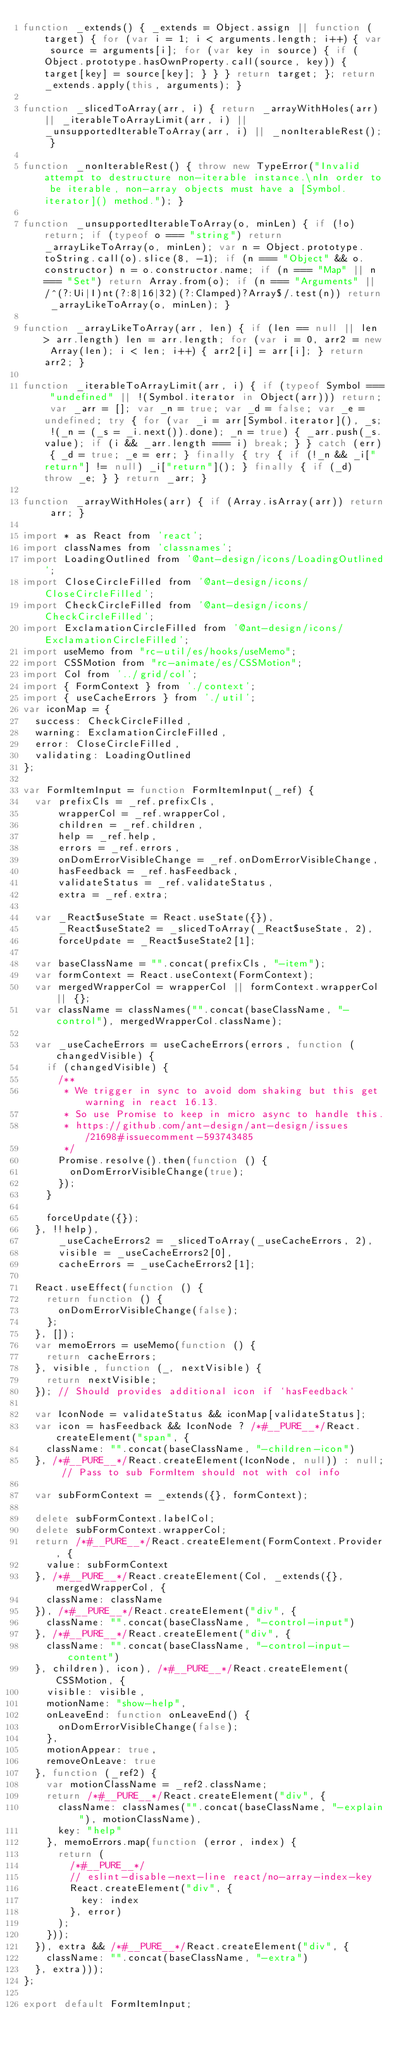Convert code to text. <code><loc_0><loc_0><loc_500><loc_500><_JavaScript_>function _extends() { _extends = Object.assign || function (target) { for (var i = 1; i < arguments.length; i++) { var source = arguments[i]; for (var key in source) { if (Object.prototype.hasOwnProperty.call(source, key)) { target[key] = source[key]; } } } return target; }; return _extends.apply(this, arguments); }

function _slicedToArray(arr, i) { return _arrayWithHoles(arr) || _iterableToArrayLimit(arr, i) || _unsupportedIterableToArray(arr, i) || _nonIterableRest(); }

function _nonIterableRest() { throw new TypeError("Invalid attempt to destructure non-iterable instance.\nIn order to be iterable, non-array objects must have a [Symbol.iterator]() method."); }

function _unsupportedIterableToArray(o, minLen) { if (!o) return; if (typeof o === "string") return _arrayLikeToArray(o, minLen); var n = Object.prototype.toString.call(o).slice(8, -1); if (n === "Object" && o.constructor) n = o.constructor.name; if (n === "Map" || n === "Set") return Array.from(o); if (n === "Arguments" || /^(?:Ui|I)nt(?:8|16|32)(?:Clamped)?Array$/.test(n)) return _arrayLikeToArray(o, minLen); }

function _arrayLikeToArray(arr, len) { if (len == null || len > arr.length) len = arr.length; for (var i = 0, arr2 = new Array(len); i < len; i++) { arr2[i] = arr[i]; } return arr2; }

function _iterableToArrayLimit(arr, i) { if (typeof Symbol === "undefined" || !(Symbol.iterator in Object(arr))) return; var _arr = []; var _n = true; var _d = false; var _e = undefined; try { for (var _i = arr[Symbol.iterator](), _s; !(_n = (_s = _i.next()).done); _n = true) { _arr.push(_s.value); if (i && _arr.length === i) break; } } catch (err) { _d = true; _e = err; } finally { try { if (!_n && _i["return"] != null) _i["return"](); } finally { if (_d) throw _e; } } return _arr; }

function _arrayWithHoles(arr) { if (Array.isArray(arr)) return arr; }

import * as React from 'react';
import classNames from 'classnames';
import LoadingOutlined from '@ant-design/icons/LoadingOutlined';
import CloseCircleFilled from '@ant-design/icons/CloseCircleFilled';
import CheckCircleFilled from '@ant-design/icons/CheckCircleFilled';
import ExclamationCircleFilled from '@ant-design/icons/ExclamationCircleFilled';
import useMemo from "rc-util/es/hooks/useMemo";
import CSSMotion from "rc-animate/es/CSSMotion";
import Col from '../grid/col';
import { FormContext } from './context';
import { useCacheErrors } from './util';
var iconMap = {
  success: CheckCircleFilled,
  warning: ExclamationCircleFilled,
  error: CloseCircleFilled,
  validating: LoadingOutlined
};

var FormItemInput = function FormItemInput(_ref) {
  var prefixCls = _ref.prefixCls,
      wrapperCol = _ref.wrapperCol,
      children = _ref.children,
      help = _ref.help,
      errors = _ref.errors,
      onDomErrorVisibleChange = _ref.onDomErrorVisibleChange,
      hasFeedback = _ref.hasFeedback,
      validateStatus = _ref.validateStatus,
      extra = _ref.extra;

  var _React$useState = React.useState({}),
      _React$useState2 = _slicedToArray(_React$useState, 2),
      forceUpdate = _React$useState2[1];

  var baseClassName = "".concat(prefixCls, "-item");
  var formContext = React.useContext(FormContext);
  var mergedWrapperCol = wrapperCol || formContext.wrapperCol || {};
  var className = classNames("".concat(baseClassName, "-control"), mergedWrapperCol.className);

  var _useCacheErrors = useCacheErrors(errors, function (changedVisible) {
    if (changedVisible) {
      /**
       * We trigger in sync to avoid dom shaking but this get warning in react 16.13.
       * So use Promise to keep in micro async to handle this.
       * https://github.com/ant-design/ant-design/issues/21698#issuecomment-593743485
       */
      Promise.resolve().then(function () {
        onDomErrorVisibleChange(true);
      });
    }

    forceUpdate({});
  }, !!help),
      _useCacheErrors2 = _slicedToArray(_useCacheErrors, 2),
      visible = _useCacheErrors2[0],
      cacheErrors = _useCacheErrors2[1];

  React.useEffect(function () {
    return function () {
      onDomErrorVisibleChange(false);
    };
  }, []);
  var memoErrors = useMemo(function () {
    return cacheErrors;
  }, visible, function (_, nextVisible) {
    return nextVisible;
  }); // Should provides additional icon if `hasFeedback`

  var IconNode = validateStatus && iconMap[validateStatus];
  var icon = hasFeedback && IconNode ? /*#__PURE__*/React.createElement("span", {
    className: "".concat(baseClassName, "-children-icon")
  }, /*#__PURE__*/React.createElement(IconNode, null)) : null; // Pass to sub FormItem should not with col info

  var subFormContext = _extends({}, formContext);

  delete subFormContext.labelCol;
  delete subFormContext.wrapperCol;
  return /*#__PURE__*/React.createElement(FormContext.Provider, {
    value: subFormContext
  }, /*#__PURE__*/React.createElement(Col, _extends({}, mergedWrapperCol, {
    className: className
  }), /*#__PURE__*/React.createElement("div", {
    className: "".concat(baseClassName, "-control-input")
  }, /*#__PURE__*/React.createElement("div", {
    className: "".concat(baseClassName, "-control-input-content")
  }, children), icon), /*#__PURE__*/React.createElement(CSSMotion, {
    visible: visible,
    motionName: "show-help",
    onLeaveEnd: function onLeaveEnd() {
      onDomErrorVisibleChange(false);
    },
    motionAppear: true,
    removeOnLeave: true
  }, function (_ref2) {
    var motionClassName = _ref2.className;
    return /*#__PURE__*/React.createElement("div", {
      className: classNames("".concat(baseClassName, "-explain"), motionClassName),
      key: "help"
    }, memoErrors.map(function (error, index) {
      return (
        /*#__PURE__*/
        // eslint-disable-next-line react/no-array-index-key
        React.createElement("div", {
          key: index
        }, error)
      );
    }));
  }), extra && /*#__PURE__*/React.createElement("div", {
    className: "".concat(baseClassName, "-extra")
  }, extra)));
};

export default FormItemInput;</code> 